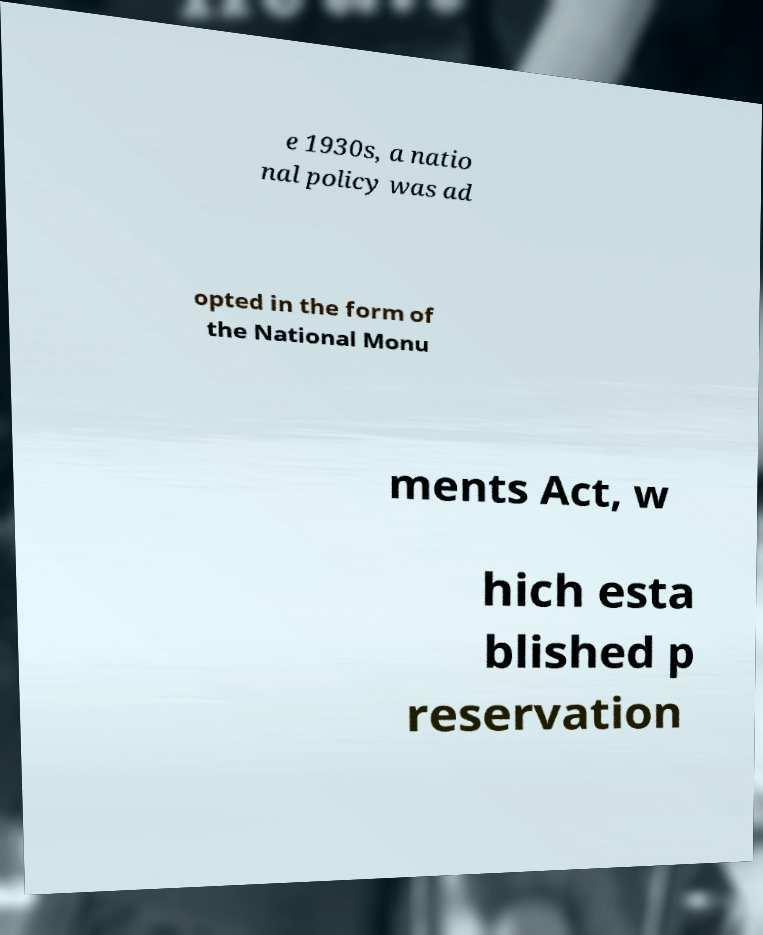What messages or text are displayed in this image? I need them in a readable, typed format. e 1930s, a natio nal policy was ad opted in the form of the National Monu ments Act, w hich esta blished p reservation 